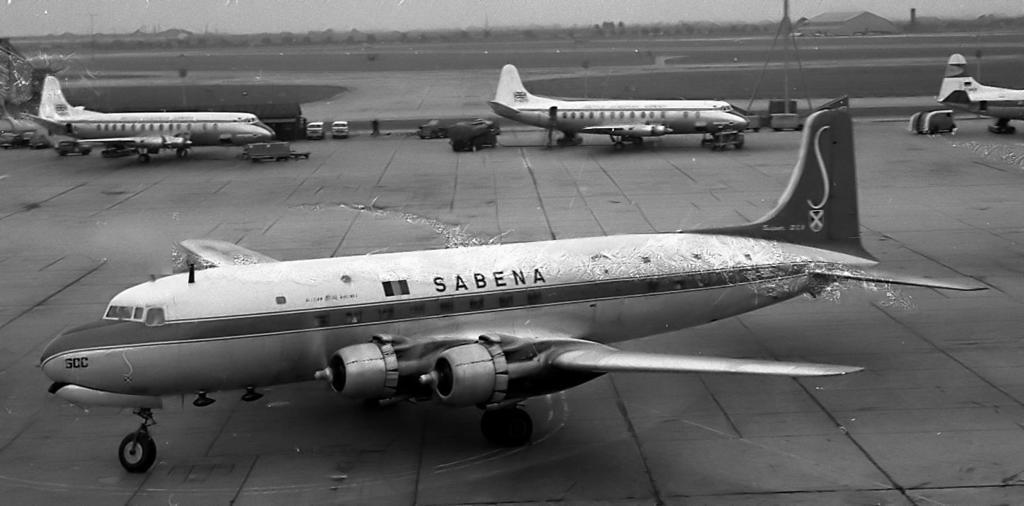Describe this image in one or two sentences. This picture is black and white image. In this picture we can see aeroplanes, trucks, poles are there. At the top of the image we can see house, trees, sky are present. At the bottom of the image there is a ground. 